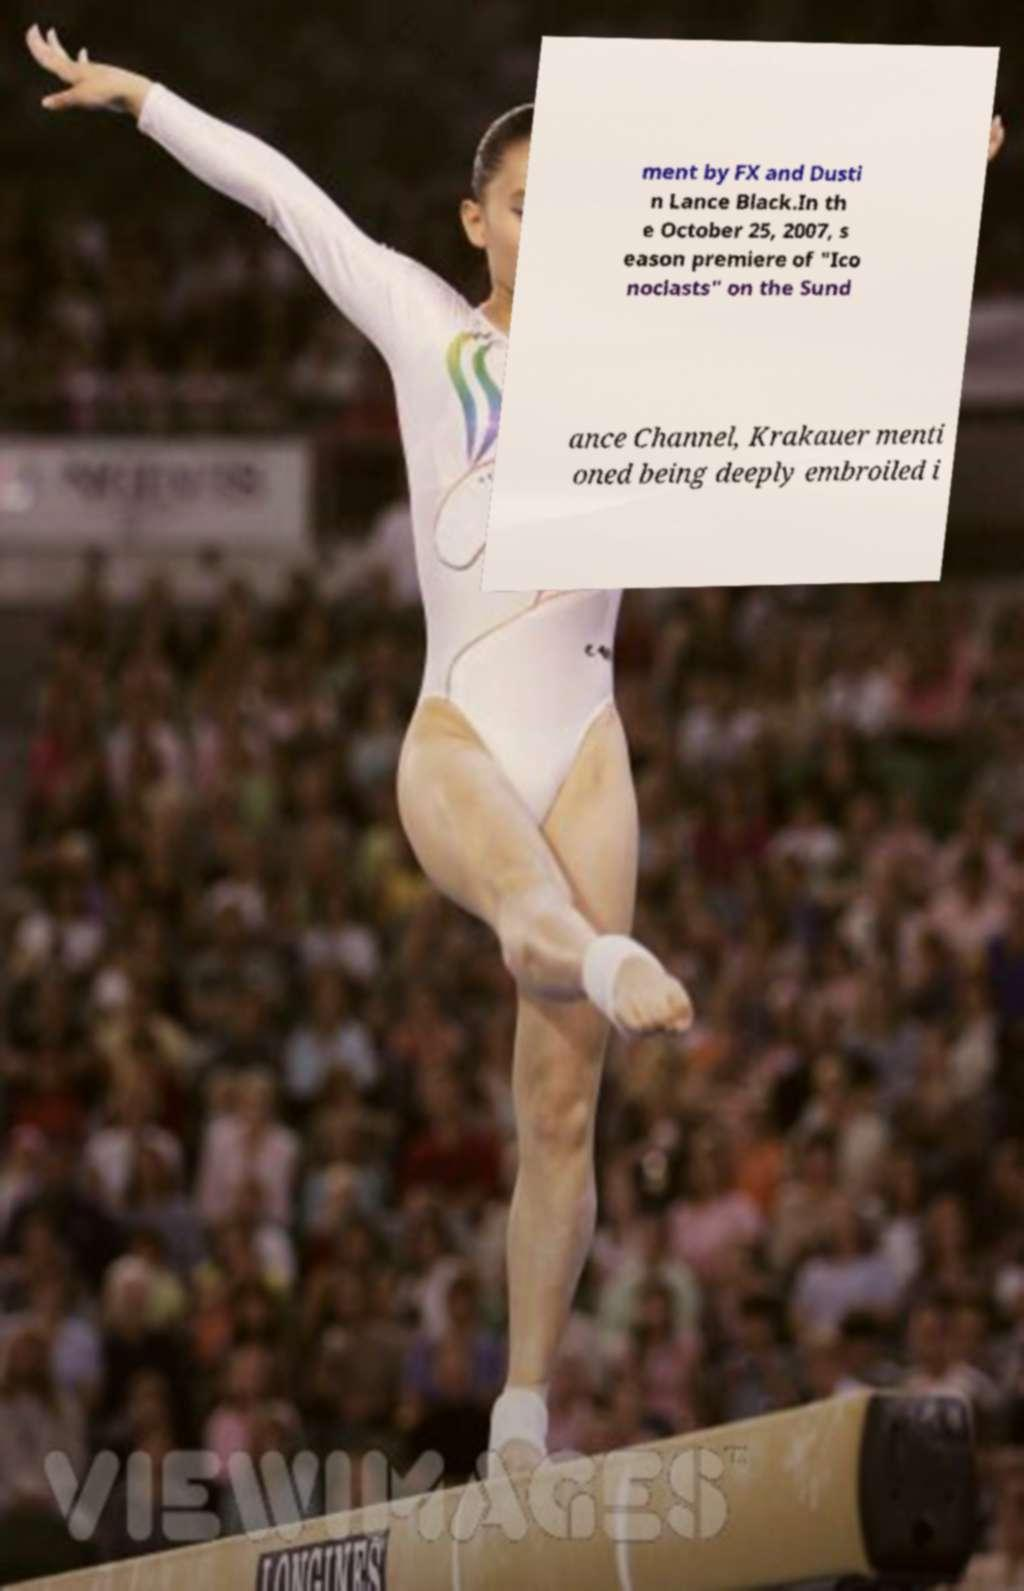For documentation purposes, I need the text within this image transcribed. Could you provide that? ment by FX and Dusti n Lance Black.In th e October 25, 2007, s eason premiere of "Ico noclasts" on the Sund ance Channel, Krakauer menti oned being deeply embroiled i 